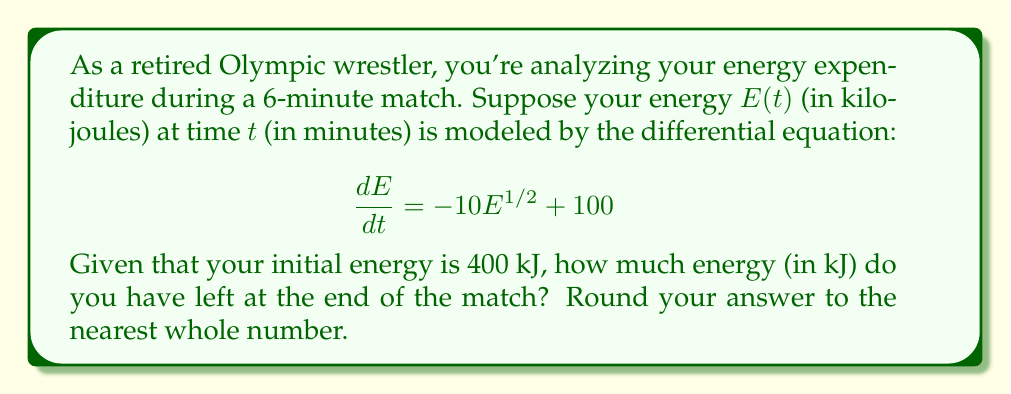Can you answer this question? Let's solve this problem step-by-step:

1) We have the differential equation:
   $$\frac{dE}{dt} = -10E^{1/2} + 100$$

2) This is a separable equation. Let's rearrange it:
   $$\frac{dE}{-10E^{1/2} + 100} = dt$$

3) Integrate both sides:
   $$\int \frac{dE}{-10E^{1/2} + 100} = \int dt$$

4) The left side can be integrated using substitution. Let $u = E^{1/2}$, then $du = \frac{1}{2}E^{-1/2}dE$ or $dE = 2udu$:
   $$-\frac{1}{5}\int \frac{2udu}{-10u + 100} = t + C$$

5) This integrates to:
   $$\frac{1}{5}\ln|-10u + 100| = t + C$$

6) Substituting back $u = E^{1/2}$:
   $$\frac{1}{5}\ln|-10E^{1/2} + 100| = t + C$$

7) Now, use the initial condition: at $t=0$, $E=400$:
   $$\frac{1}{5}\ln|-10(400^{1/2}) + 100| = 0 + C$$
   $$\frac{1}{5}\ln|100| = C$$
   $$C = \frac{\ln 100}{5}$$

8) The general solution is:
   $$\frac{1}{5}\ln|-10E^{1/2} + 100| = t + \frac{\ln 100}{5}$$

9) To find $E$ at $t=6$, substitute these values:
   $$\frac{1}{5}\ln|-10E^{1/2} + 100| = 6 + \frac{\ln 100}{5}$$

10) Solve for $E$:
    $$\ln|-10E^{1/2} + 100| = 30 + \ln 100$$
    $$|-10E^{1/2} + 100| = e^{30} \cdot 100$$
    $$-10E^{1/2} + 100 = e^{30} \cdot 100$$ (since the left side is always positive)
    $$E^{1/2} = 10 - \frac{e^{30} \cdot 100}{10}$$
    $$E = (10 - \frac{e^{30} \cdot 100}{10})^2$$

11) Calculate this value and round to the nearest whole number:
    $$E \approx 81 \text{ kJ}$$
Answer: 81 kJ 